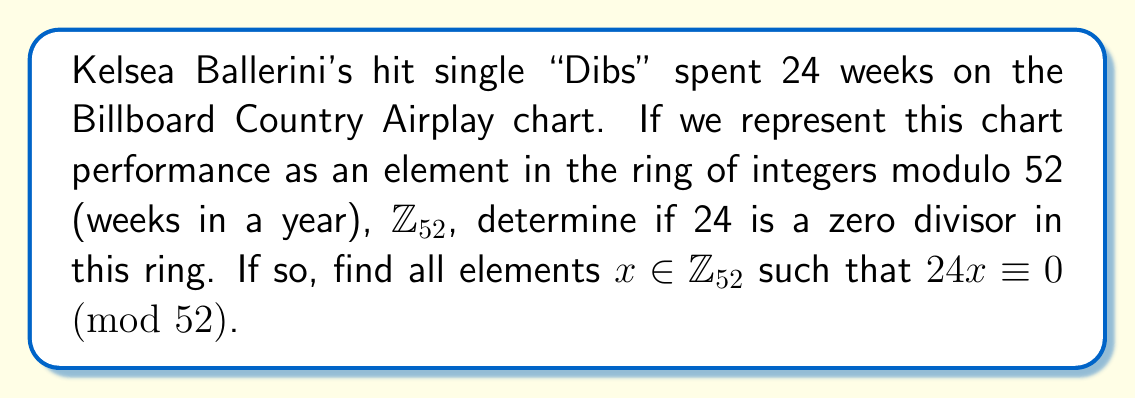Solve this math problem. To determine if 24 is a zero divisor in $\mathbb{Z}_{52}$, we need to check if there exists a non-zero element $x \in \mathbb{Z}_{52}$ such that $24x \equiv 0 \pmod{52}$.

Step 1: Find the greatest common divisor (GCD) of 24 and 52.
$\gcd(24, 52) = 4$

Step 2: Since the GCD is not 1, 24 is a zero divisor in $\mathbb{Z}_{52}$.

Step 3: To find all elements $x$ such that $24x \equiv 0 \pmod{52}$, we solve the congruence:
$24x \equiv 0 \pmod{52}$

Step 4: Divide both sides by $\gcd(24, 52) = 4$:
$6x \equiv 0 \pmod{13}$

Step 5: The solutions to this congruence are multiples of 13 in $\mathbb{Z}_{52}$:
$x \equiv 0, 13, 26, 39 \pmod{52}$

Therefore, the zero divisors paired with 24 in $\mathbb{Z}_{52}$ are 13, 26, and 39.
Answer: 24 is a zero divisor; its paired zero divisors are 13, 26, and 39 in $\mathbb{Z}_{52}$. 